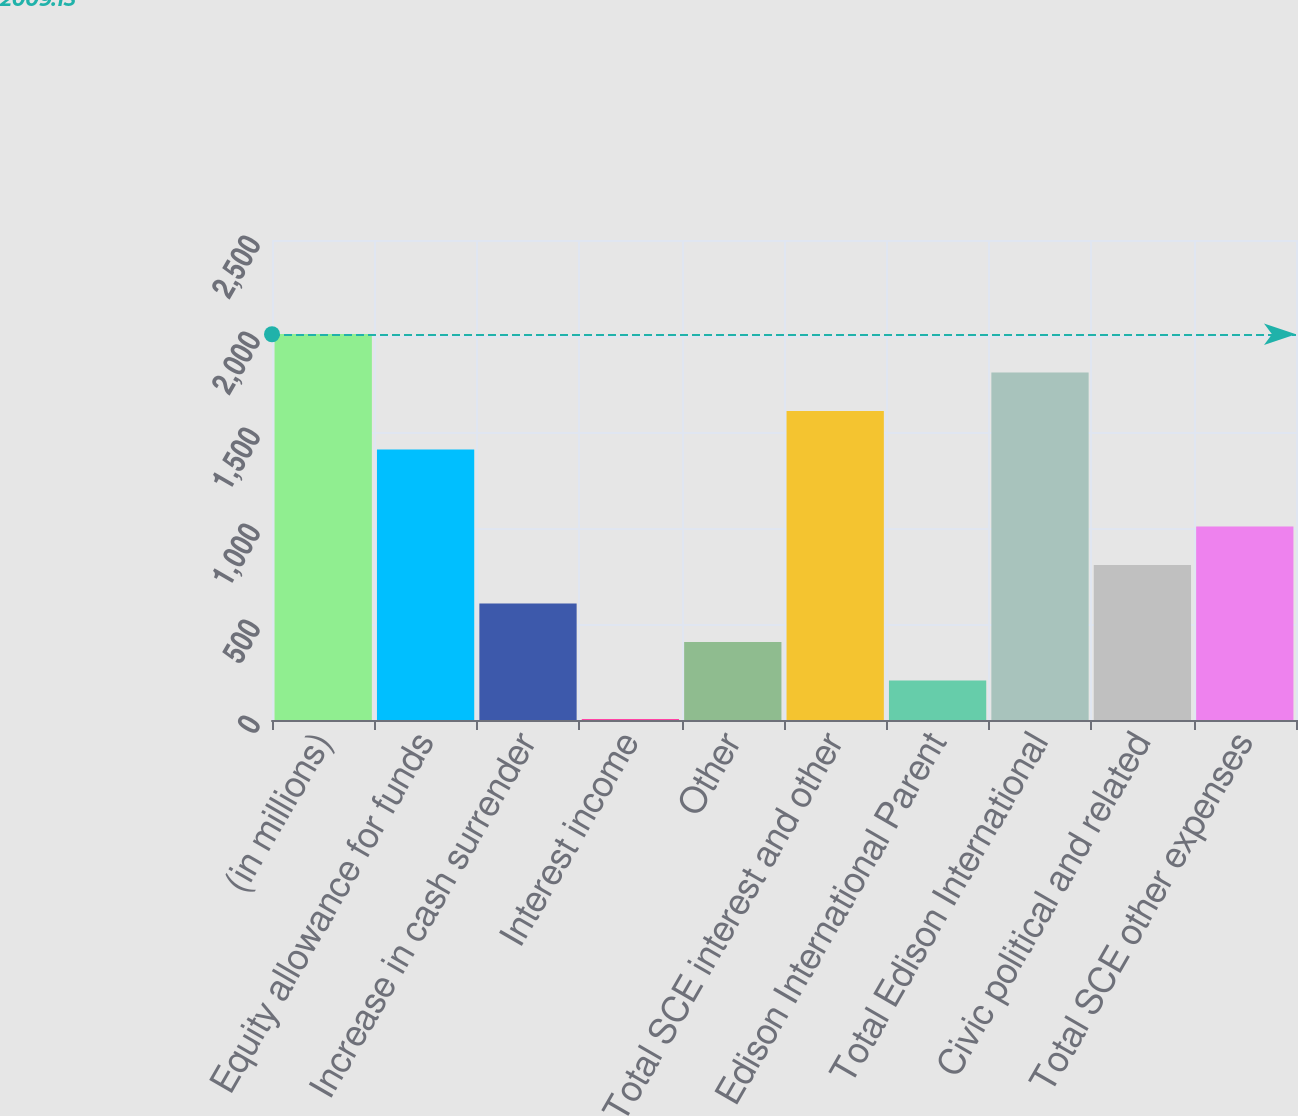Convert chart to OTSL. <chart><loc_0><loc_0><loc_500><loc_500><bar_chart><fcel>(in millions)<fcel>Equity allowance for funds<fcel>Increase in cash surrender<fcel>Interest income<fcel>Other<fcel>Total SCE interest and other<fcel>Edison International Parent<fcel>Total Edison International<fcel>Civic political and related<fcel>Total SCE other expenses<nl><fcel>2011<fcel>1409.2<fcel>606.8<fcel>5<fcel>406.2<fcel>1609.8<fcel>205.6<fcel>1810.4<fcel>807.4<fcel>1008<nl></chart> 